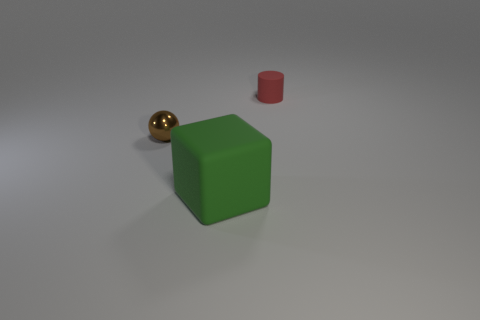Add 1 small things. How many objects exist? 4 Subtract all spheres. How many objects are left? 2 Subtract 0 yellow spheres. How many objects are left? 3 Subtract all cubes. Subtract all small red cylinders. How many objects are left? 1 Add 3 red things. How many red things are left? 4 Add 3 big yellow shiny cylinders. How many big yellow shiny cylinders exist? 3 